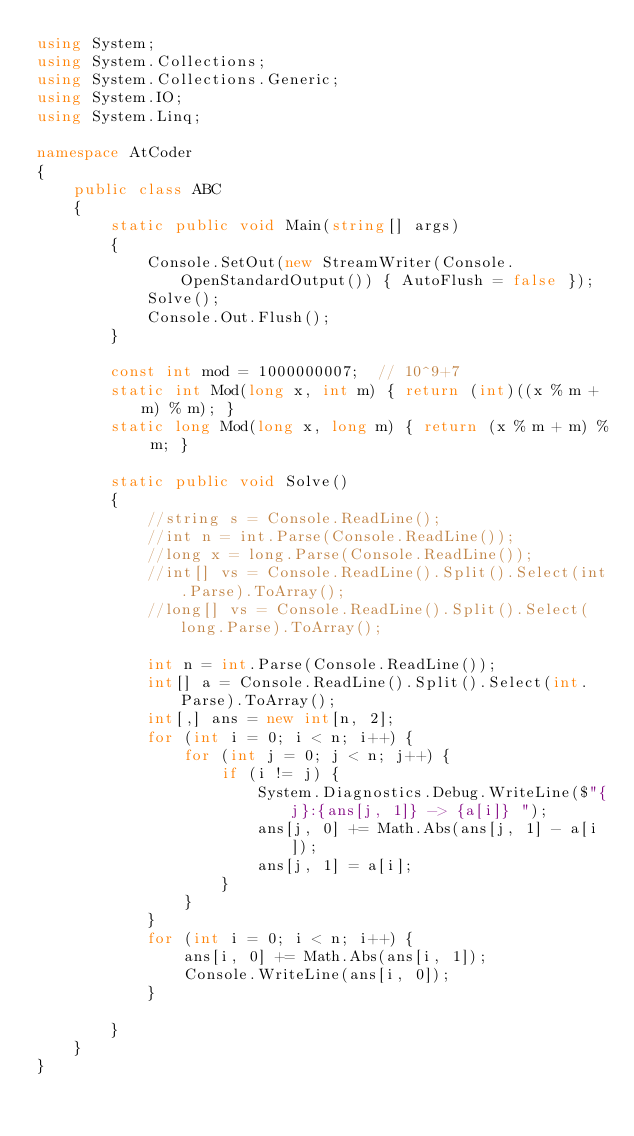<code> <loc_0><loc_0><loc_500><loc_500><_C#_>using System;
using System.Collections;
using System.Collections.Generic;
using System.IO;
using System.Linq;

namespace AtCoder
{
	public class ABC
	{
		static public void Main(string[] args)
		{
			Console.SetOut(new StreamWriter(Console.OpenStandardOutput()) { AutoFlush = false });
			Solve();
			Console.Out.Flush();
		}

		const int mod = 1000000007;  // 10^9+7
		static int Mod(long x, int m) { return (int)((x % m + m) % m); }
		static long Mod(long x, long m) { return (x % m + m) % m; }

		static public void Solve()
		{
			//string s = Console.ReadLine();
			//int n = int.Parse(Console.ReadLine());
			//long x = long.Parse(Console.ReadLine());
			//int[] vs = Console.ReadLine().Split().Select(int.Parse).ToArray();
			//long[] vs = Console.ReadLine().Split().Select(long.Parse).ToArray();

			int n = int.Parse(Console.ReadLine());
			int[] a = Console.ReadLine().Split().Select(int.Parse).ToArray();
			int[,] ans = new int[n, 2];
			for (int i = 0; i < n; i++) {
				for (int j = 0; j < n; j++) {
					if (i != j) {
						System.Diagnostics.Debug.WriteLine($"{j}:{ans[j, 1]} -> {a[i]} ");
						ans[j, 0] += Math.Abs(ans[j, 1] - a[i]);
						ans[j, 1] = a[i];
					}
				}
			}
			for (int i = 0; i < n; i++) {
				ans[i, 0] += Math.Abs(ans[i, 1]);
				Console.WriteLine(ans[i, 0]);
			}

		}
	}
}
</code> 